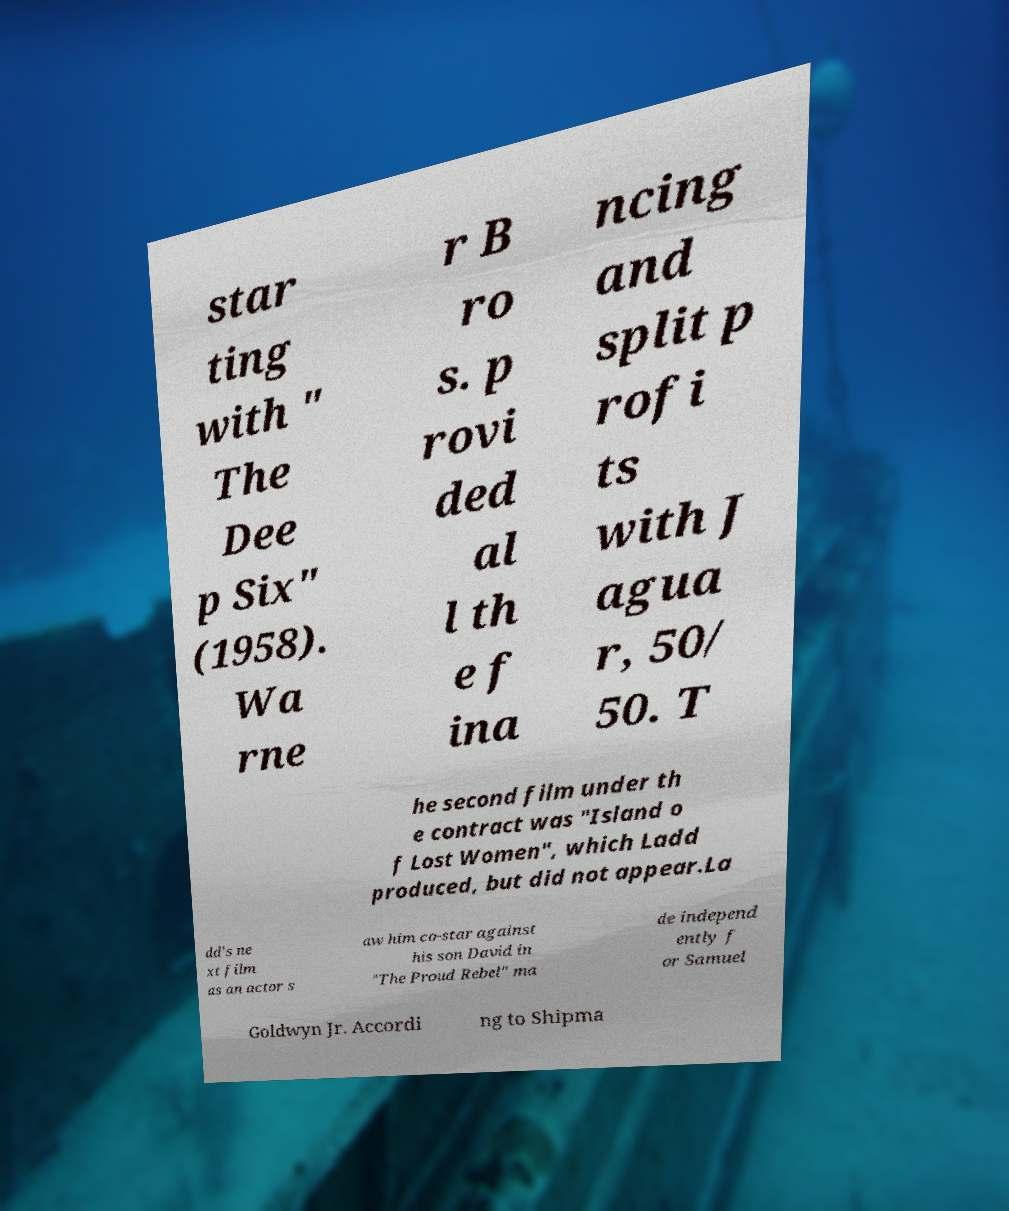I need the written content from this picture converted into text. Can you do that? star ting with " The Dee p Six" (1958). Wa rne r B ro s. p rovi ded al l th e f ina ncing and split p rofi ts with J agua r, 50/ 50. T he second film under th e contract was "Island o f Lost Women", which Ladd produced, but did not appear.La dd's ne xt film as an actor s aw him co-star against his son David in "The Proud Rebel" ma de independ ently f or Samuel Goldwyn Jr. Accordi ng to Shipma 